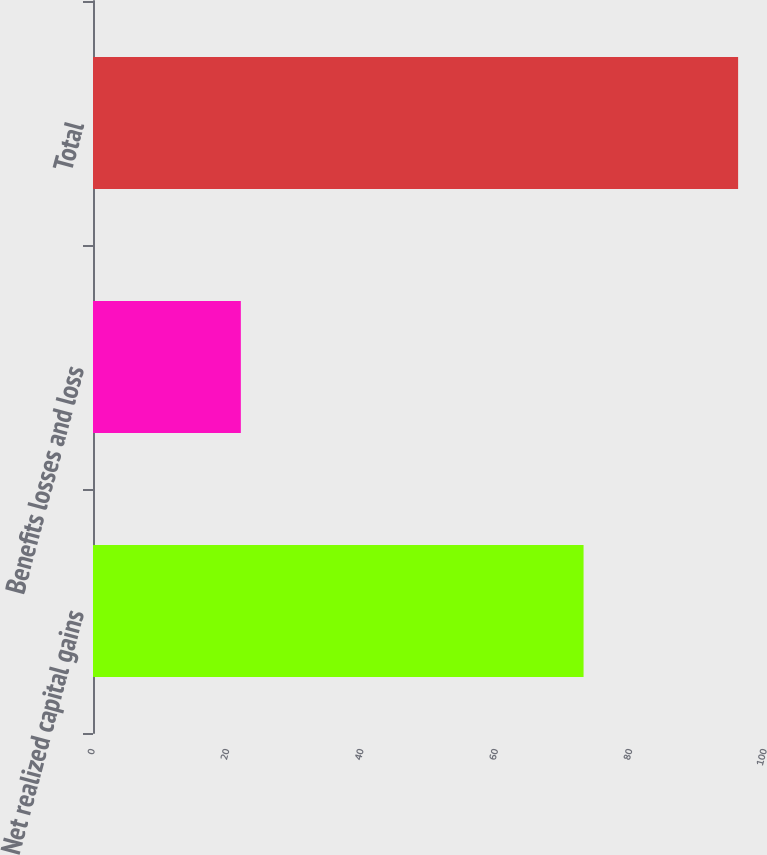<chart> <loc_0><loc_0><loc_500><loc_500><bar_chart><fcel>Net realized capital gains<fcel>Benefits losses and loss<fcel>Total<nl><fcel>73<fcel>22<fcel>96<nl></chart> 